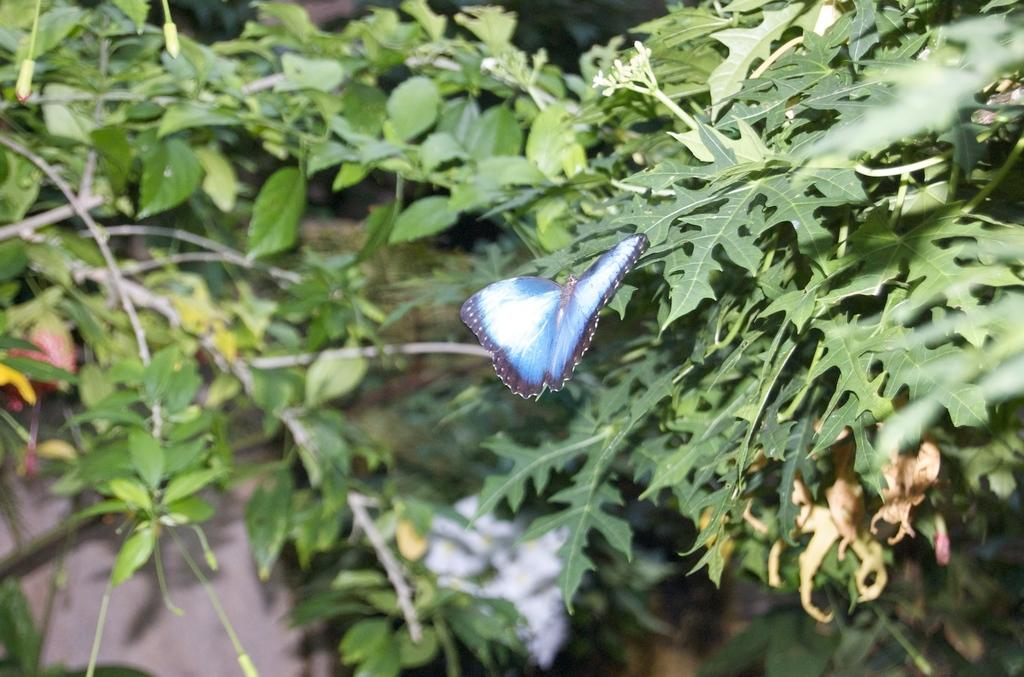What is the main subject of the image? There is a butterfly in the image. Where is the butterfly located? The butterfly is on a plant. What colors can be seen on the butterfly? The butterfly has blue, white, and purple colors. Can you see any zebras swimming in the ocean in the image? There is no zebra or ocean present in the image; it features a butterfly on a plant. 